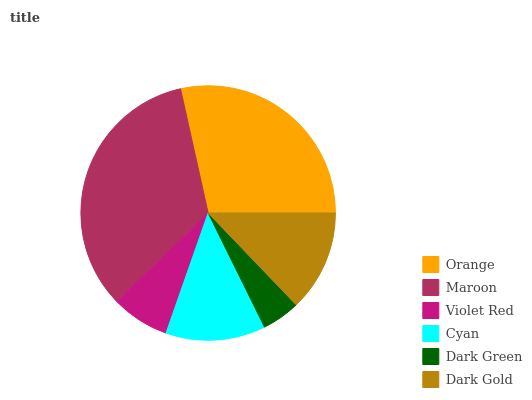Is Dark Green the minimum?
Answer yes or no. Yes. Is Maroon the maximum?
Answer yes or no. Yes. Is Violet Red the minimum?
Answer yes or no. No. Is Violet Red the maximum?
Answer yes or no. No. Is Maroon greater than Violet Red?
Answer yes or no. Yes. Is Violet Red less than Maroon?
Answer yes or no. Yes. Is Violet Red greater than Maroon?
Answer yes or no. No. Is Maroon less than Violet Red?
Answer yes or no. No. Is Dark Gold the high median?
Answer yes or no. Yes. Is Cyan the low median?
Answer yes or no. Yes. Is Dark Green the high median?
Answer yes or no. No. Is Violet Red the low median?
Answer yes or no. No. 